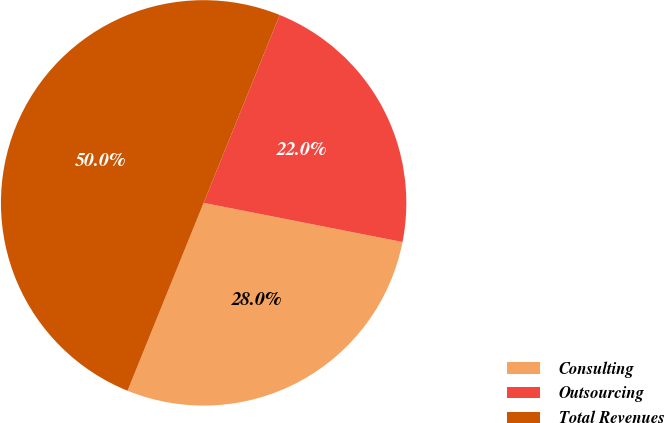<chart> <loc_0><loc_0><loc_500><loc_500><pie_chart><fcel>Consulting<fcel>Outsourcing<fcel>Total Revenues<nl><fcel>28.03%<fcel>21.97%<fcel>50.0%<nl></chart> 